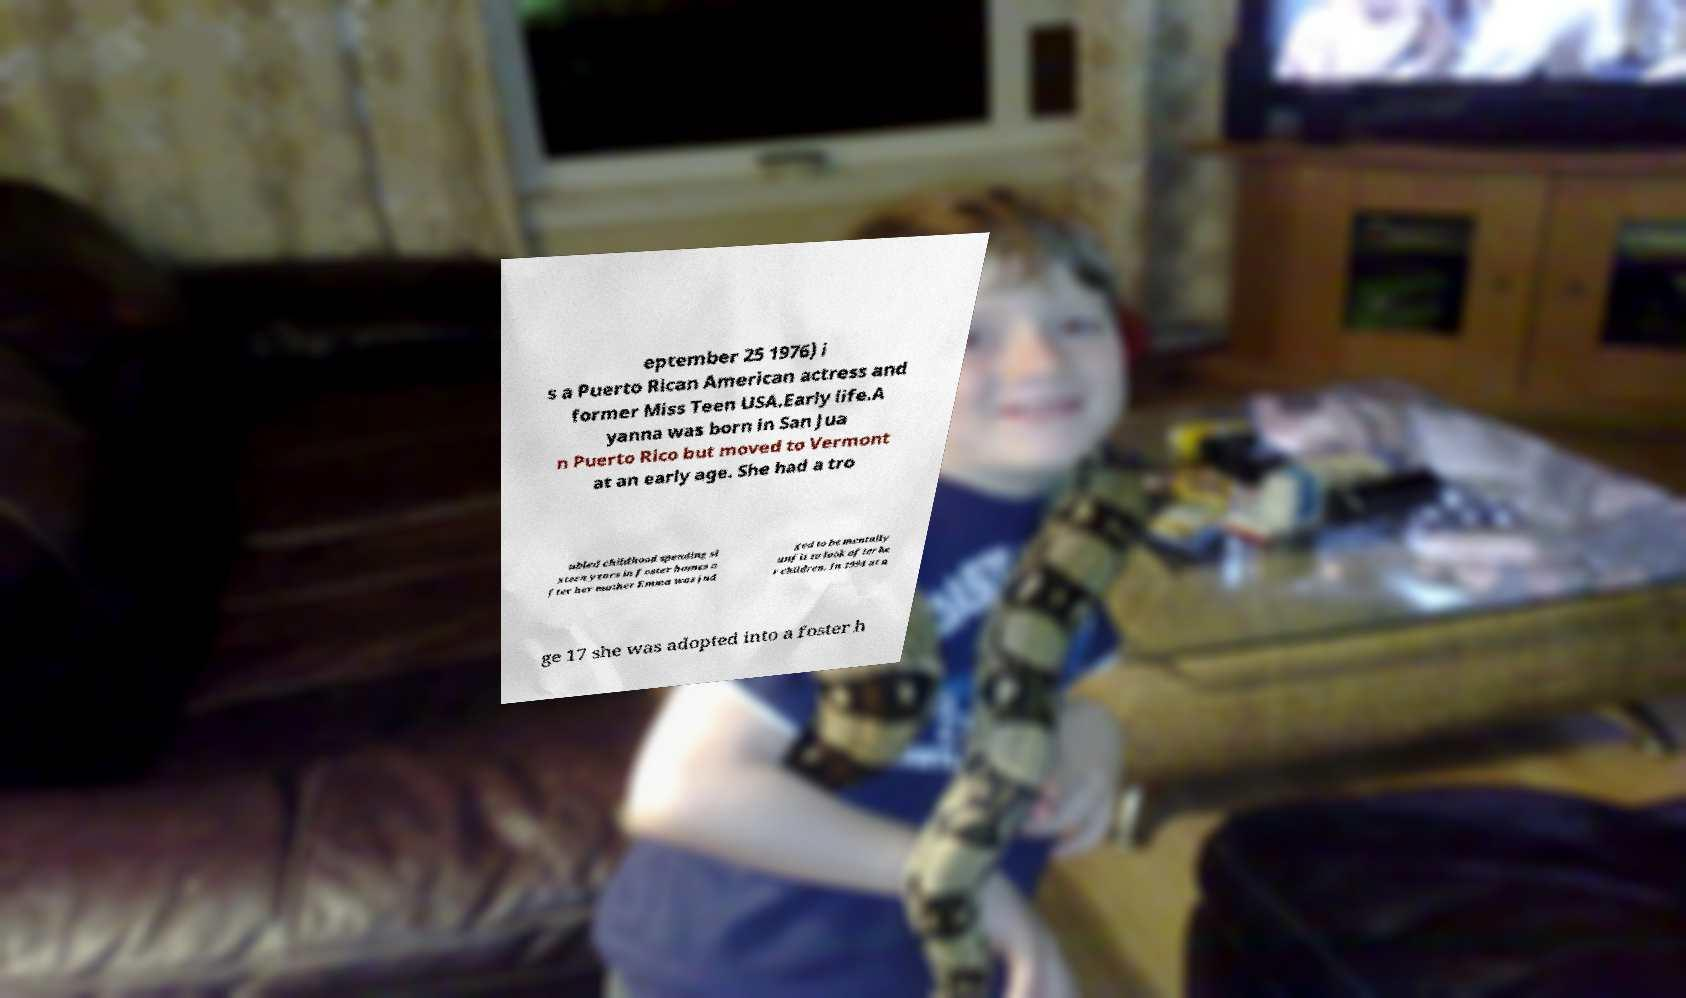For documentation purposes, I need the text within this image transcribed. Could you provide that? eptember 25 1976) i s a Puerto Rican American actress and former Miss Teen USA.Early life.A yanna was born in San Jua n Puerto Rico but moved to Vermont at an early age. She had a tro ubled childhood spending si xteen years in foster homes a fter her mother Emma was jud ged to be mentally unfit to look after he r children. In 1994 at a ge 17 she was adopted into a foster h 